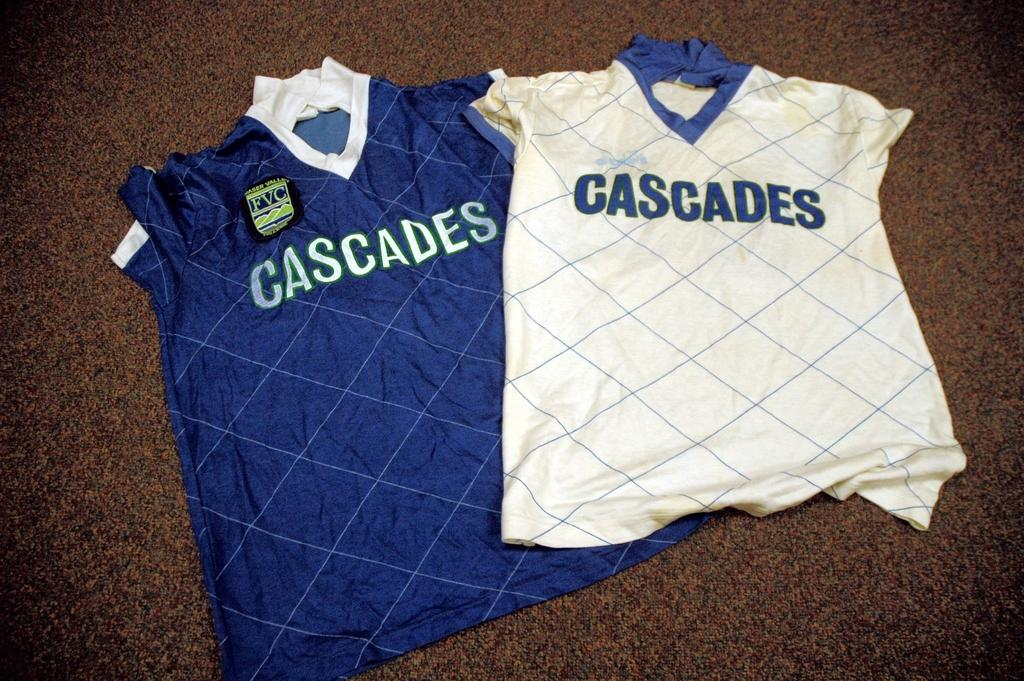<image>
Describe the image concisely. Blue and white jerseys on the floor that say Cascades on the front. 